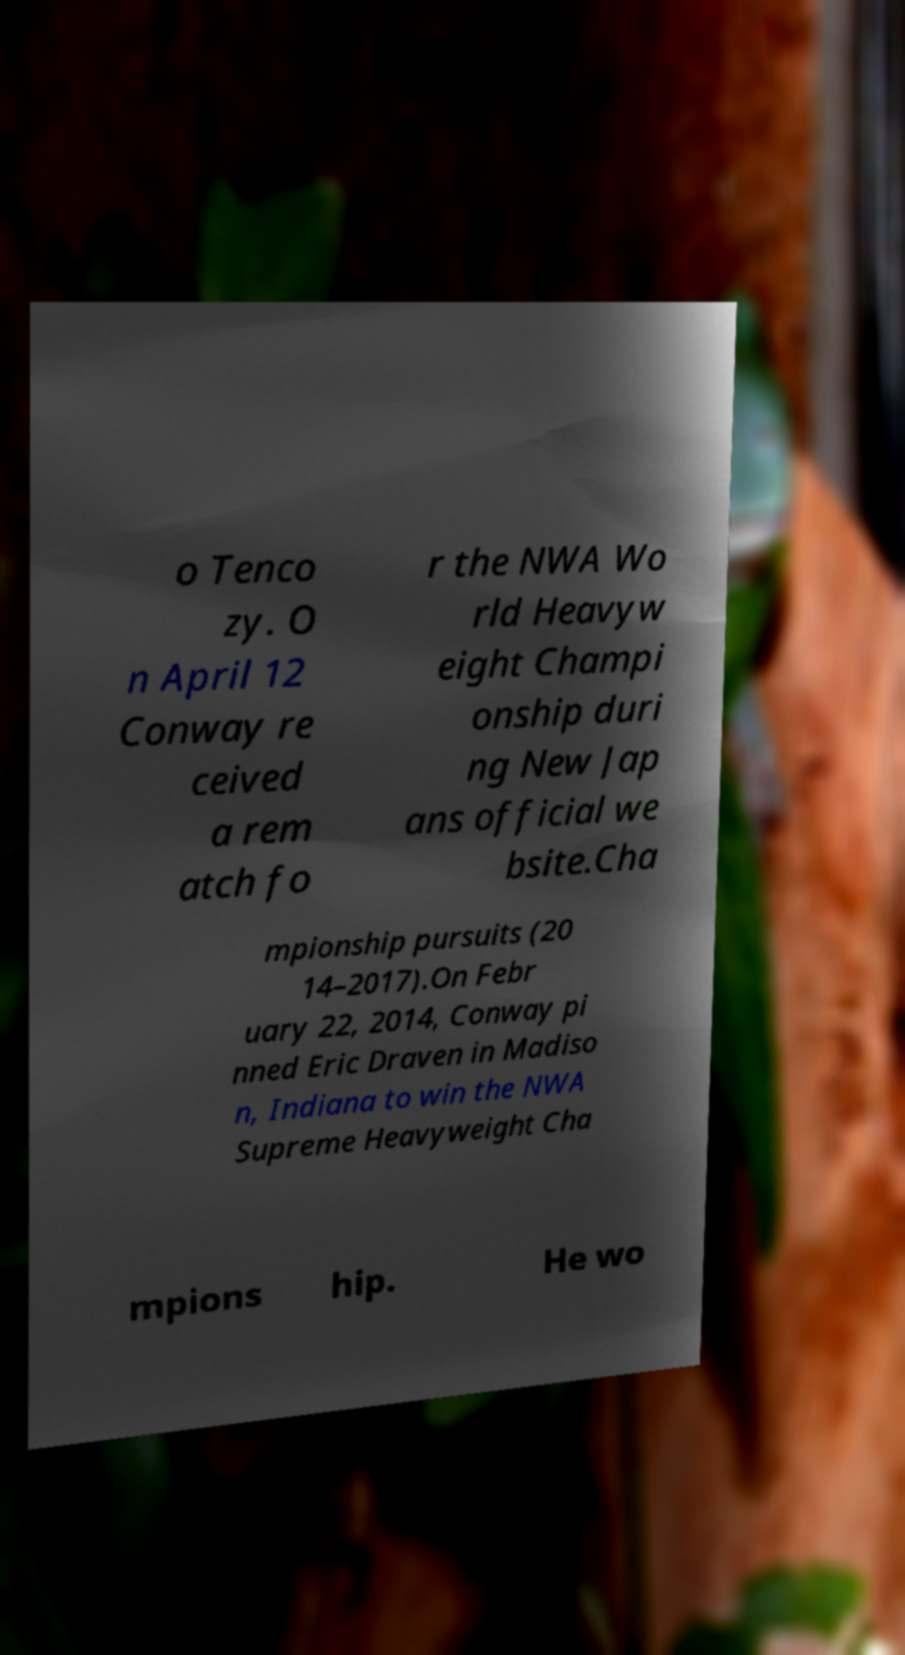Please read and relay the text visible in this image. What does it say? o Tenco zy. O n April 12 Conway re ceived a rem atch fo r the NWA Wo rld Heavyw eight Champi onship duri ng New Jap ans official we bsite.Cha mpionship pursuits (20 14–2017).On Febr uary 22, 2014, Conway pi nned Eric Draven in Madiso n, Indiana to win the NWA Supreme Heavyweight Cha mpions hip. He wo 